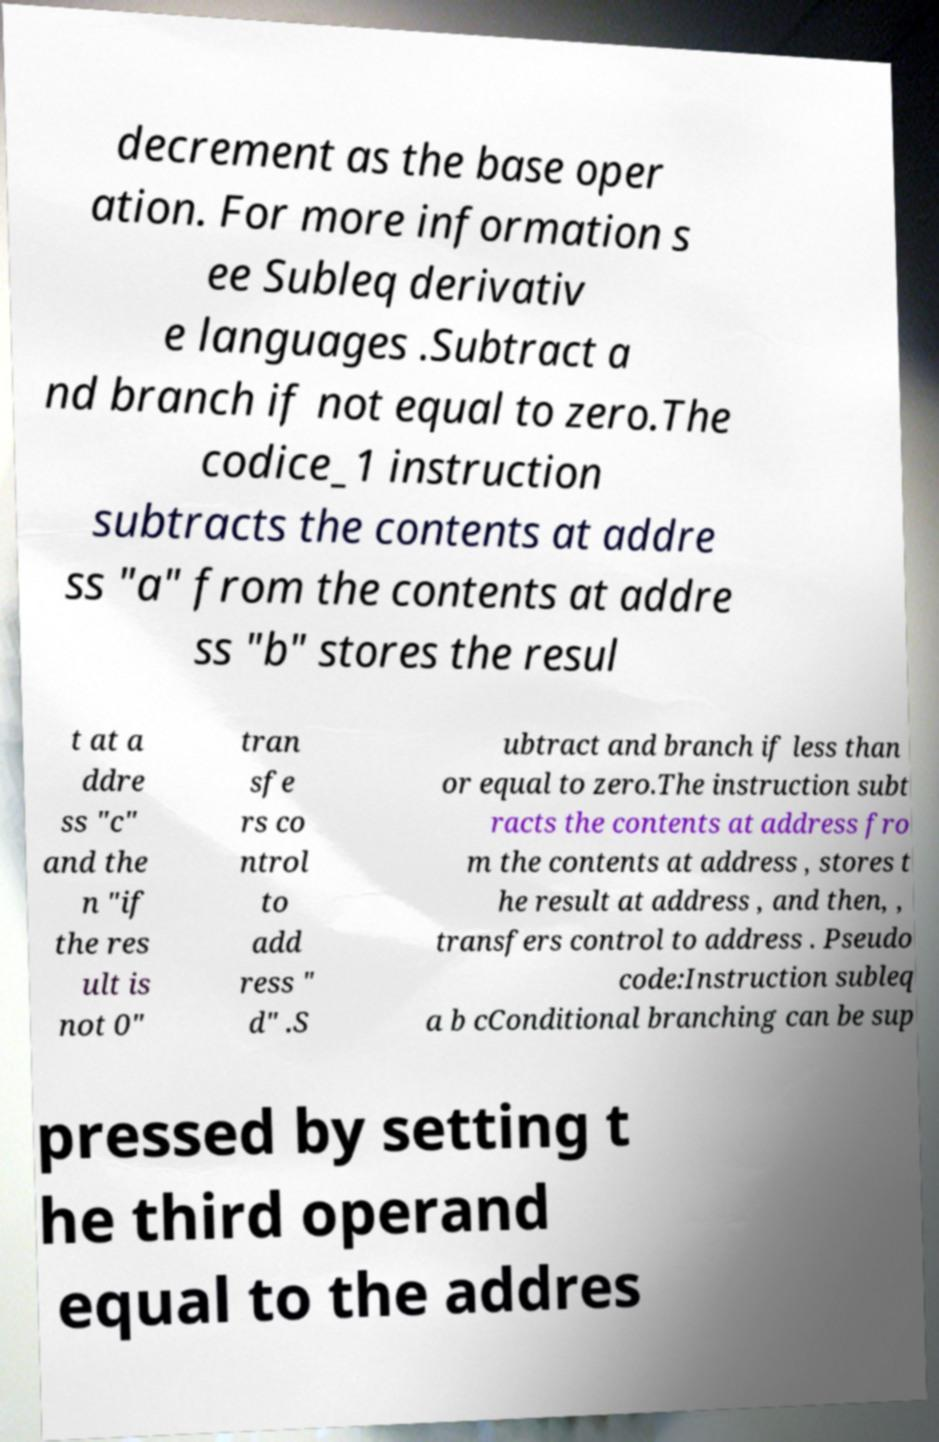Can you read and provide the text displayed in the image?This photo seems to have some interesting text. Can you extract and type it out for me? decrement as the base oper ation. For more information s ee Subleq derivativ e languages .Subtract a nd branch if not equal to zero.The codice_1 instruction subtracts the contents at addre ss "a" from the contents at addre ss "b" stores the resul t at a ddre ss "c" and the n "if the res ult is not 0" tran sfe rs co ntrol to add ress " d" .S ubtract and branch if less than or equal to zero.The instruction subt racts the contents at address fro m the contents at address , stores t he result at address , and then, , transfers control to address . Pseudo code:Instruction subleq a b cConditional branching can be sup pressed by setting t he third operand equal to the addres 